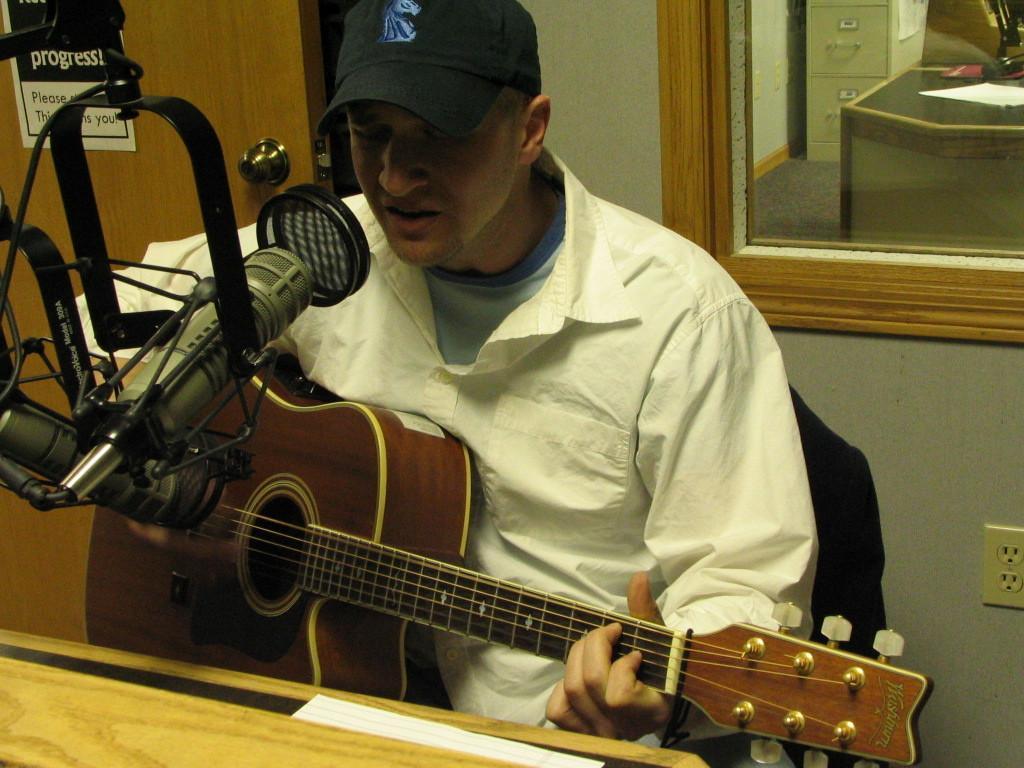Please provide a concise description of this image. In the image we can see there is a man who is sitting on chair and holding guitar in his hand and in front of him there is a mic with a stand. 